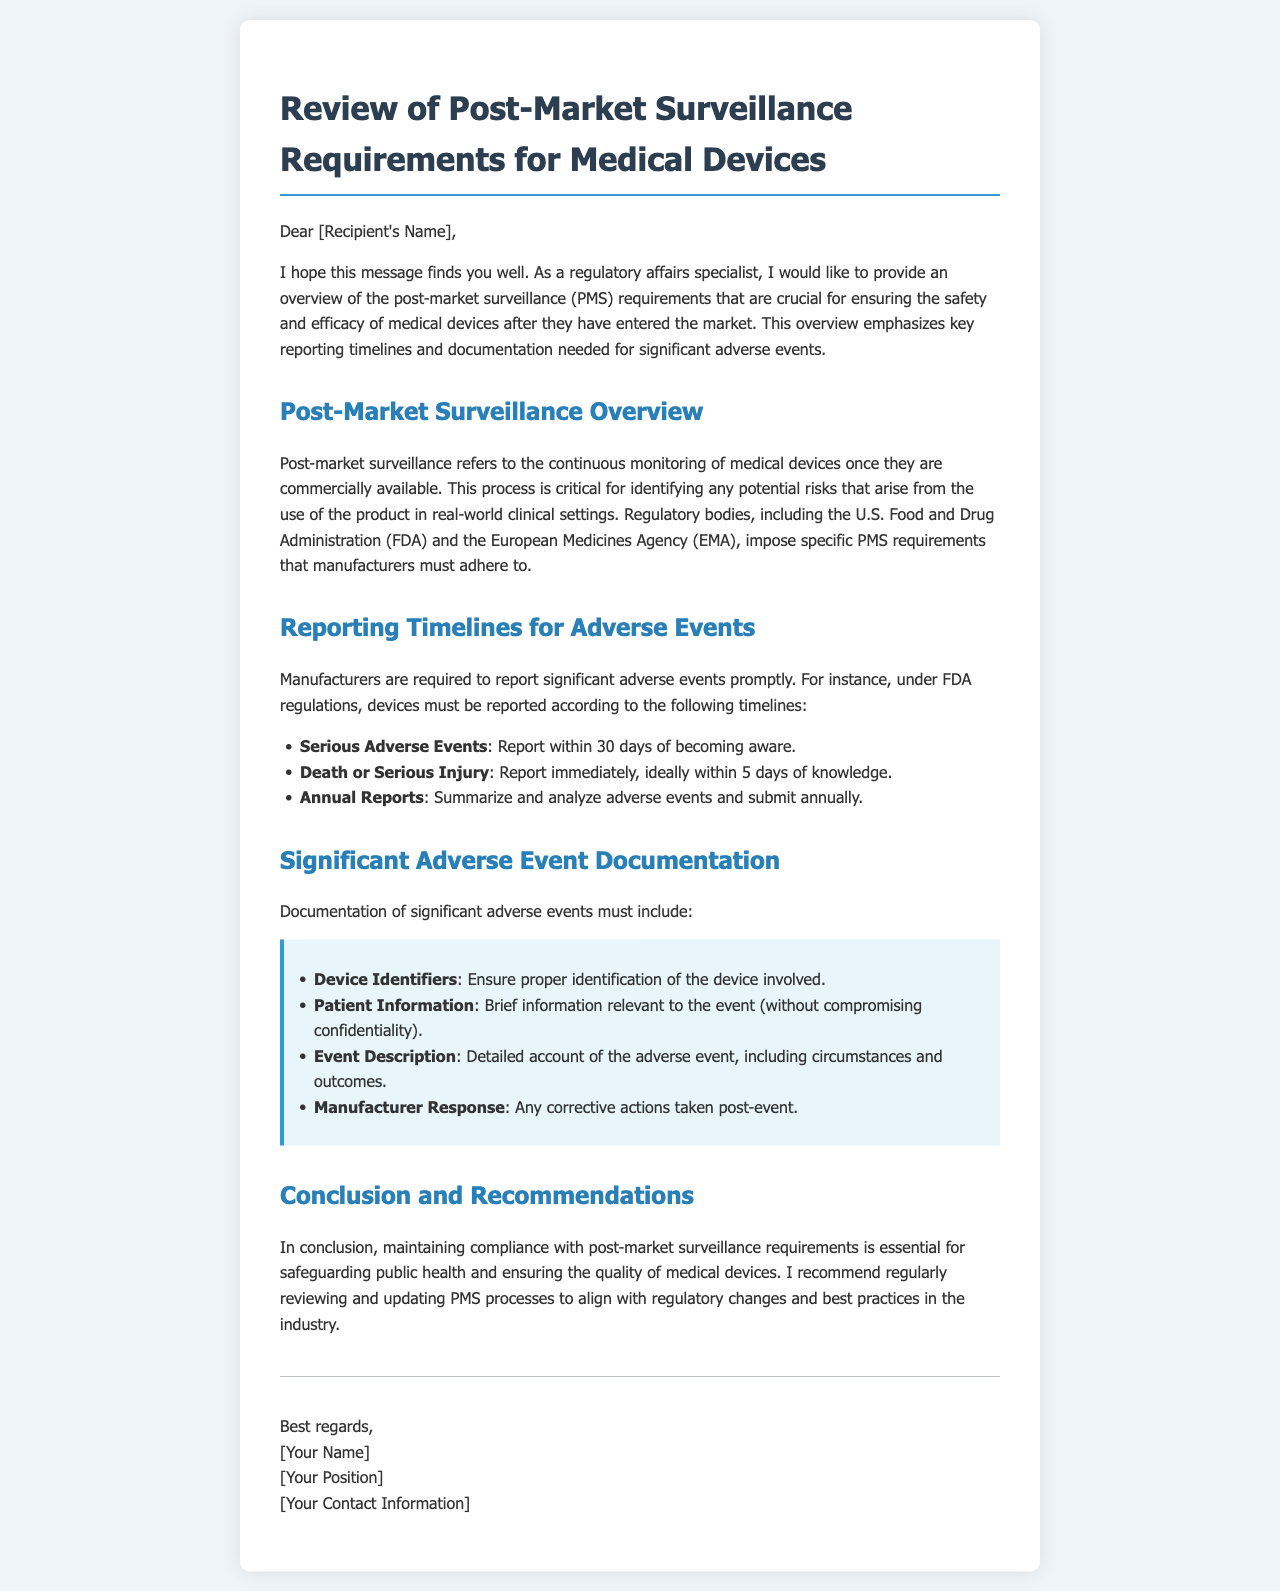What is the main purpose of post-market surveillance? The purpose is to continuously monitor medical devices after they are commercially available for identifying potential risks.
Answer: Identifying potential risks What are the reporting timelines for serious adverse events under FDA regulations? Serious adverse events must be reported within 30 days of awareness according to FDA regulations.
Answer: 30 days What should be included in the documentation of significant adverse events? Documentation must include device identifiers, patient information, event description, and manufacturer response.
Answer: Device identifiers, patient information, event description, manufacturer response What is the timeframe for reporting death or serious injury? The timeframe for reporting death or serious injury is ideally within 5 days of knowledge.
Answer: 5 days What is the frequency of submitting annual reports? Annual reports must be submitted once a year, summarizing and analyzing adverse events.
Answer: Annually 